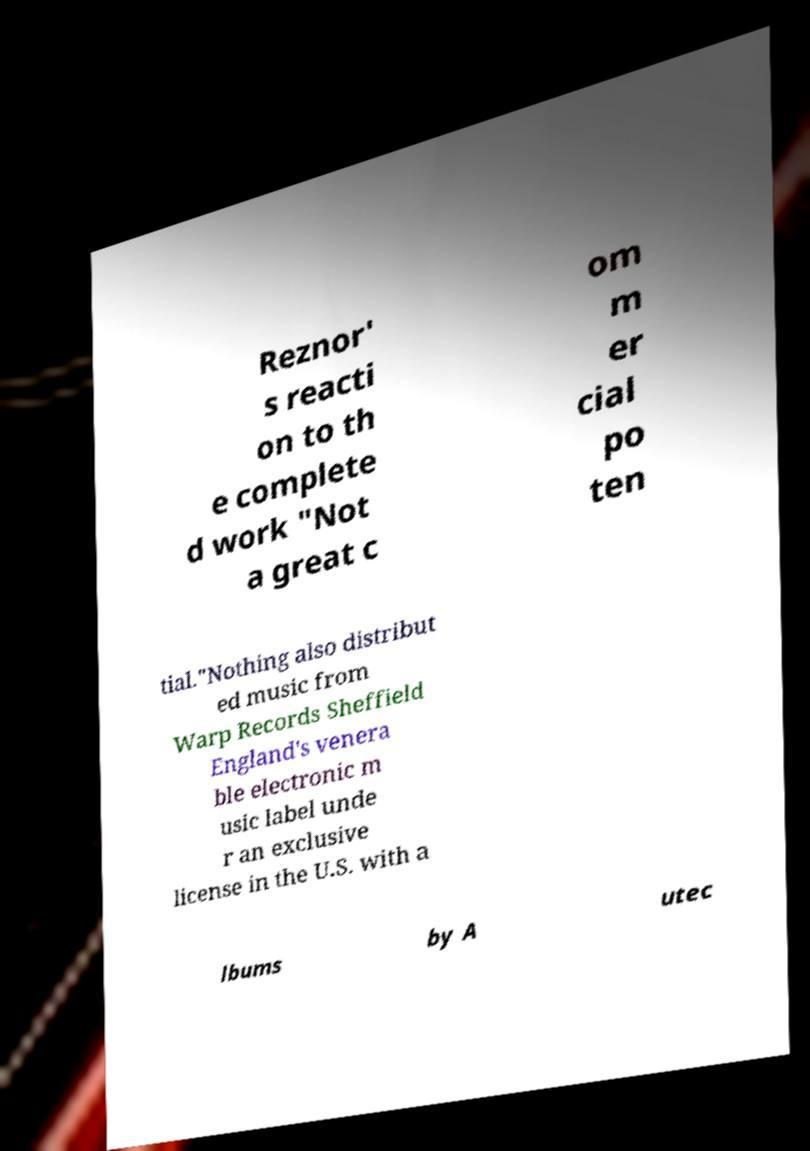Please read and relay the text visible in this image. What does it say? Reznor' s reacti on to th e complete d work "Not a great c om m er cial po ten tial."Nothing also distribut ed music from Warp Records Sheffield England's venera ble electronic m usic label unde r an exclusive license in the U.S. with a lbums by A utec 